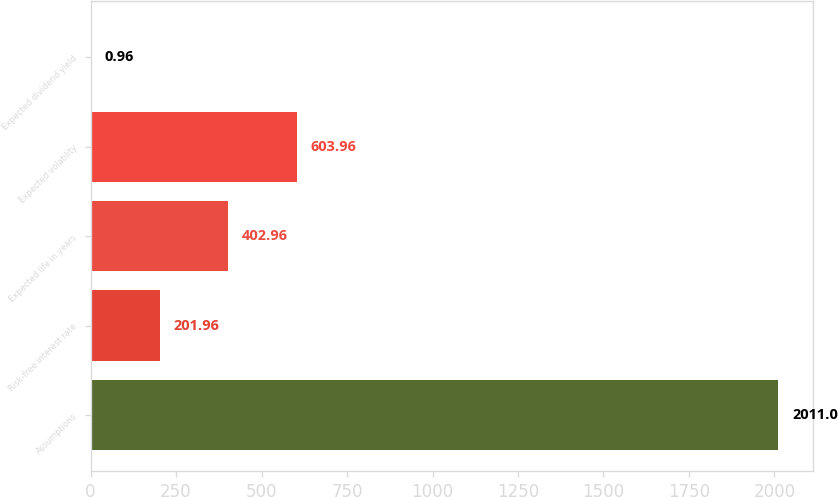Convert chart. <chart><loc_0><loc_0><loc_500><loc_500><bar_chart><fcel>Assumptions<fcel>Risk-free interest rate<fcel>Expected life in years<fcel>Expected volatility<fcel>Expected dividend yield<nl><fcel>2011<fcel>201.96<fcel>402.96<fcel>603.96<fcel>0.96<nl></chart> 